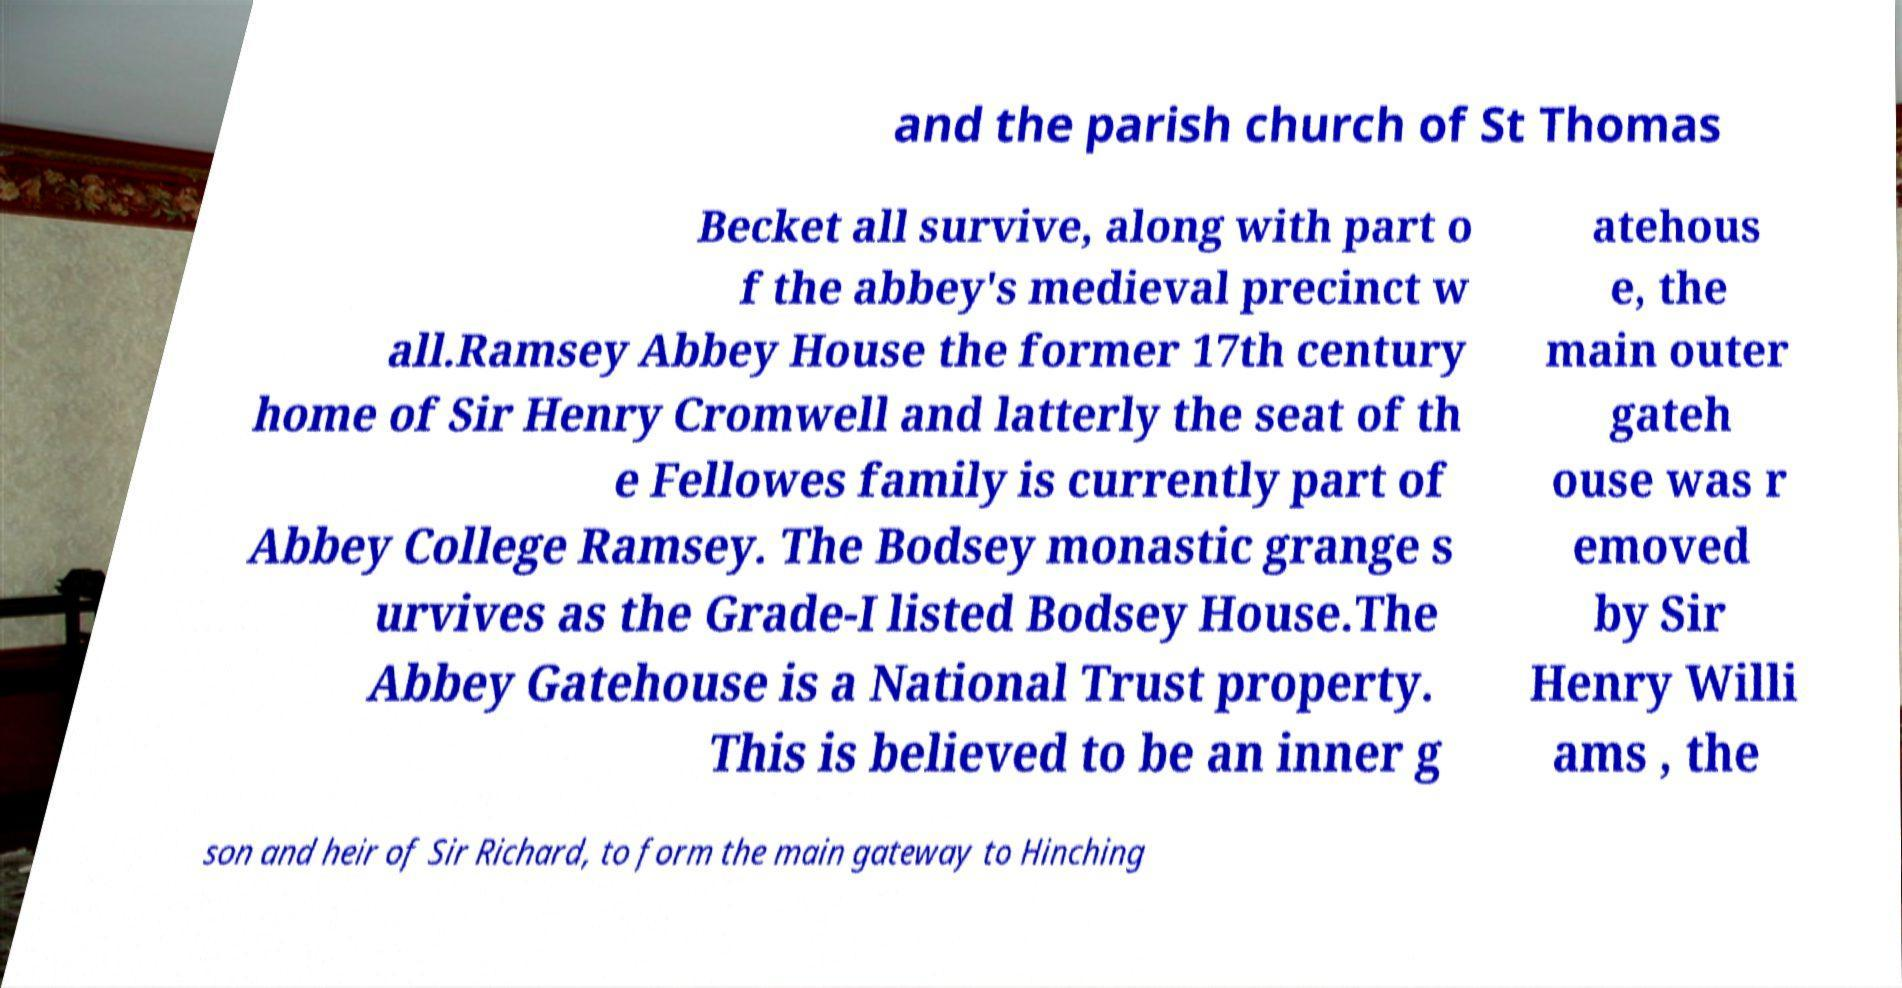Please read and relay the text visible in this image. What does it say? and the parish church of St Thomas Becket all survive, along with part o f the abbey's medieval precinct w all.Ramsey Abbey House the former 17th century home of Sir Henry Cromwell and latterly the seat of th e Fellowes family is currently part of Abbey College Ramsey. The Bodsey monastic grange s urvives as the Grade-I listed Bodsey House.The Abbey Gatehouse is a National Trust property. This is believed to be an inner g atehous e, the main outer gateh ouse was r emoved by Sir Henry Willi ams , the son and heir of Sir Richard, to form the main gateway to Hinching 